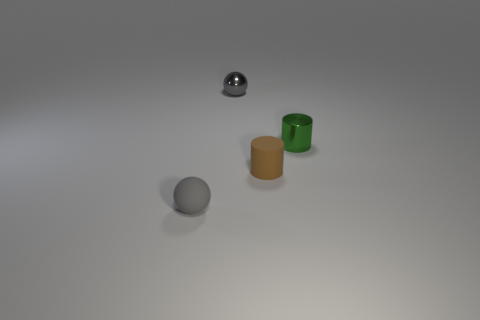Add 3 large yellow cylinders. How many objects exist? 7 Add 3 big green matte cylinders. How many big green matte cylinders exist? 3 Subtract 0 blue balls. How many objects are left? 4 Subtract all gray metal objects. Subtract all tiny brown cylinders. How many objects are left? 2 Add 3 gray spheres. How many gray spheres are left? 5 